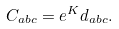Convert formula to latex. <formula><loc_0><loc_0><loc_500><loc_500>C _ { a b c } = e ^ { K } d _ { a b c } .</formula> 